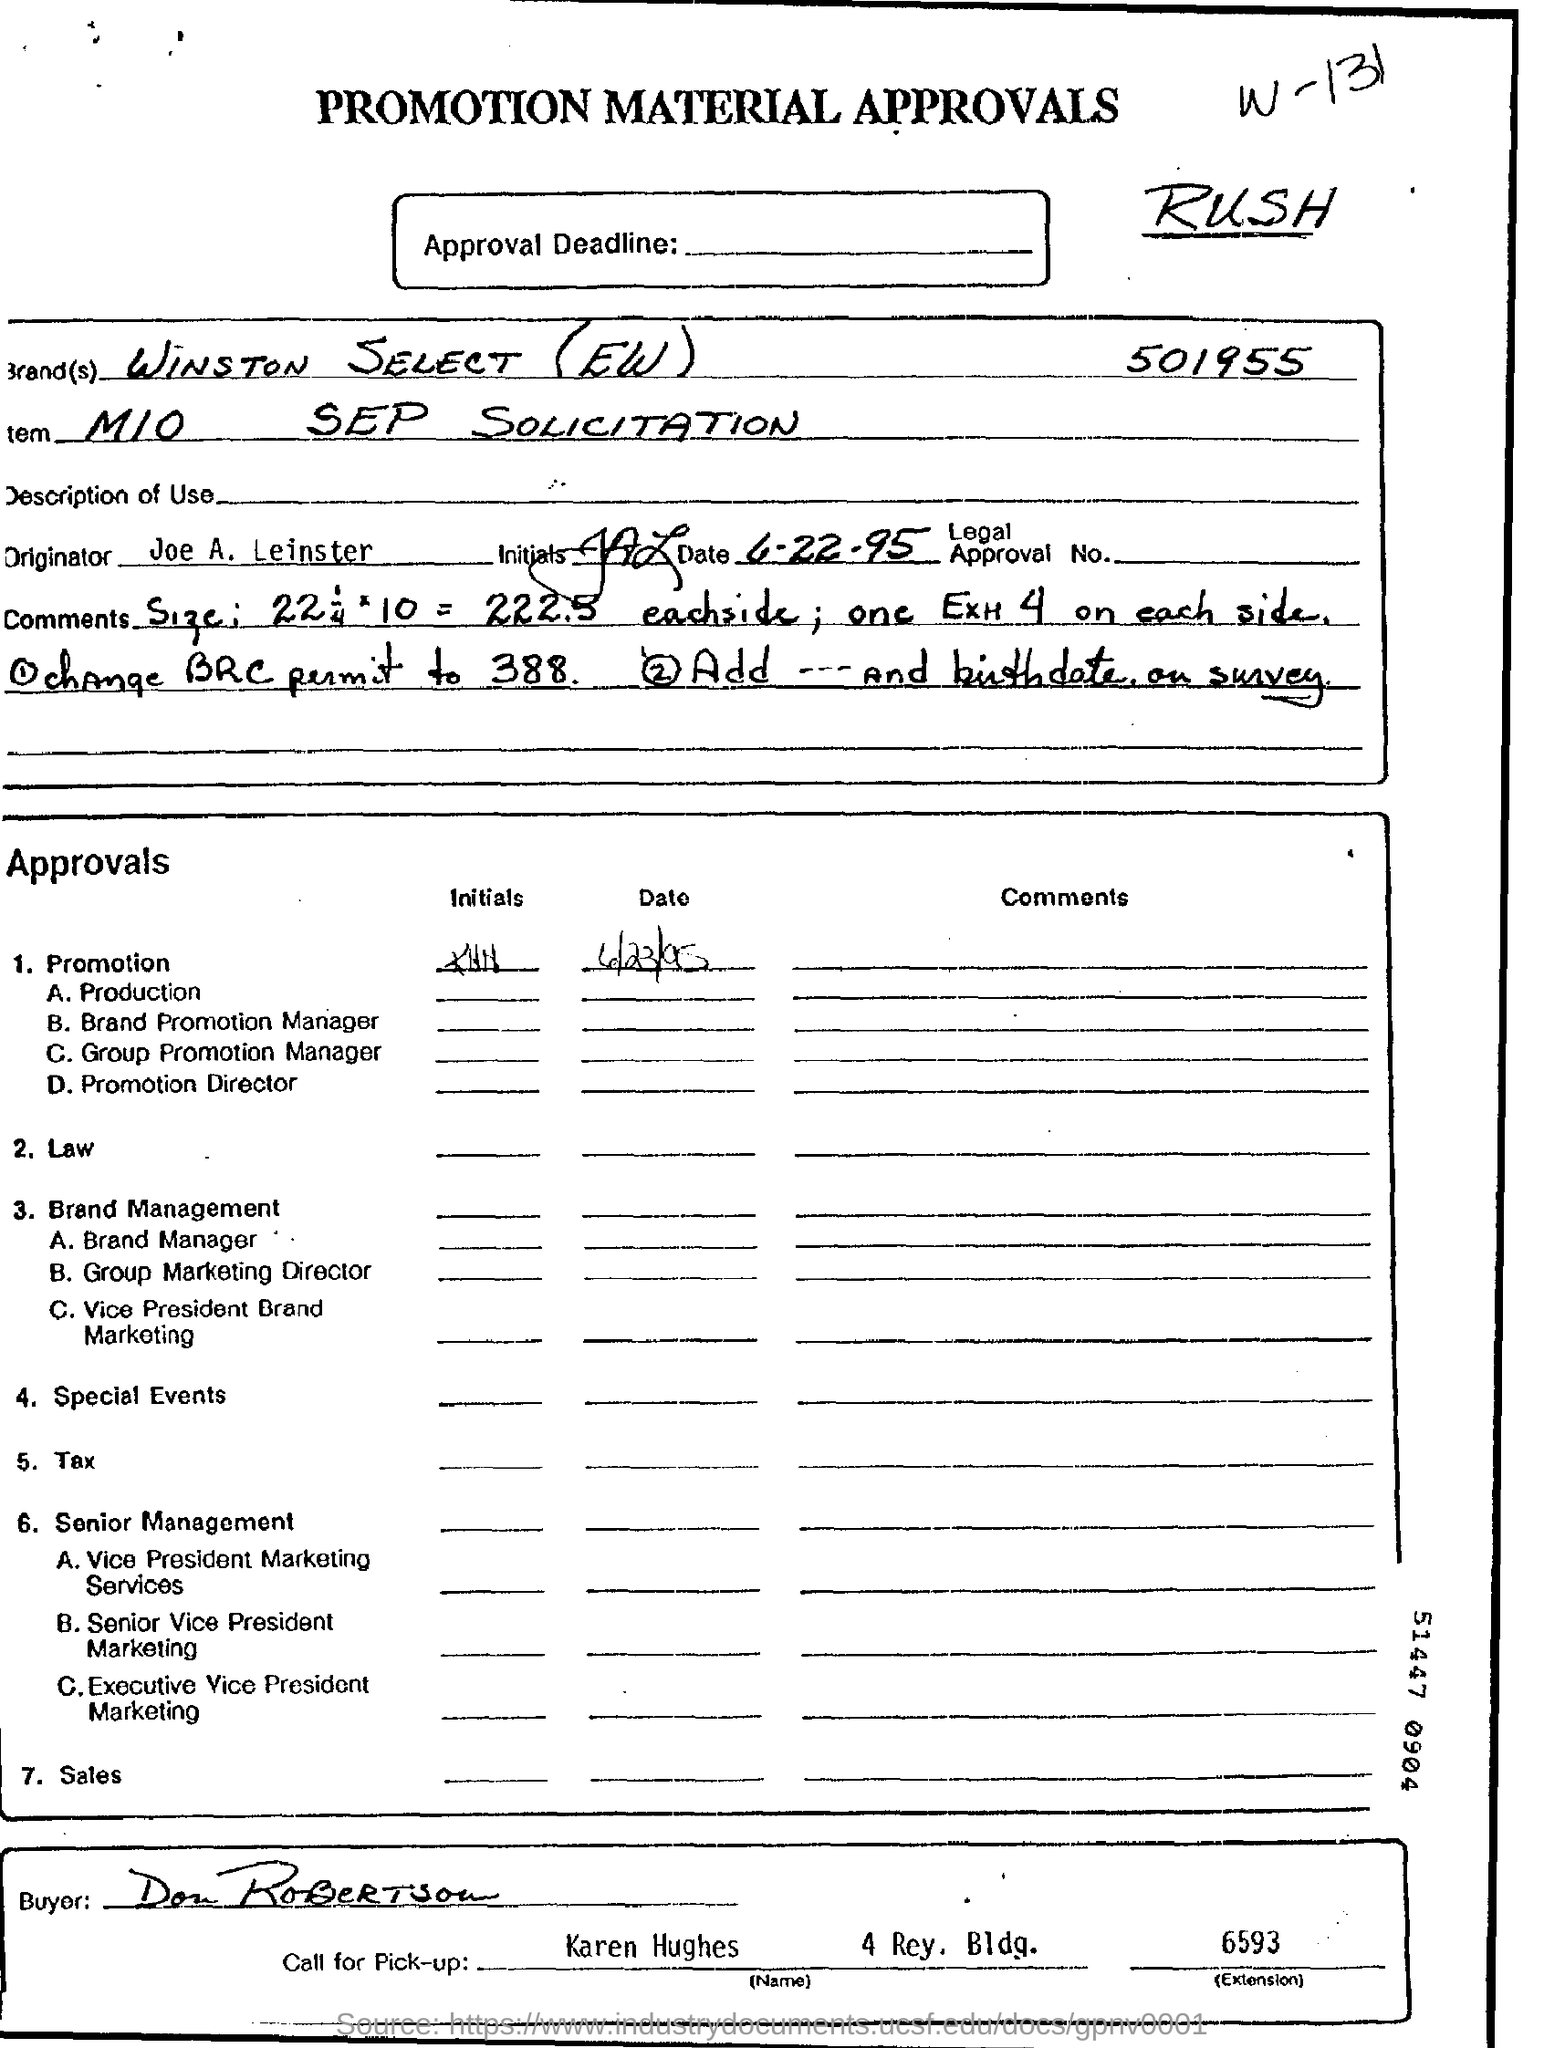Identify some key points in this picture. The document contains the date "June 22, 1995. Don Robertson is the buyer. The person who is responsible for making the "Call for Pick-Up" is named Karen Hughes. 